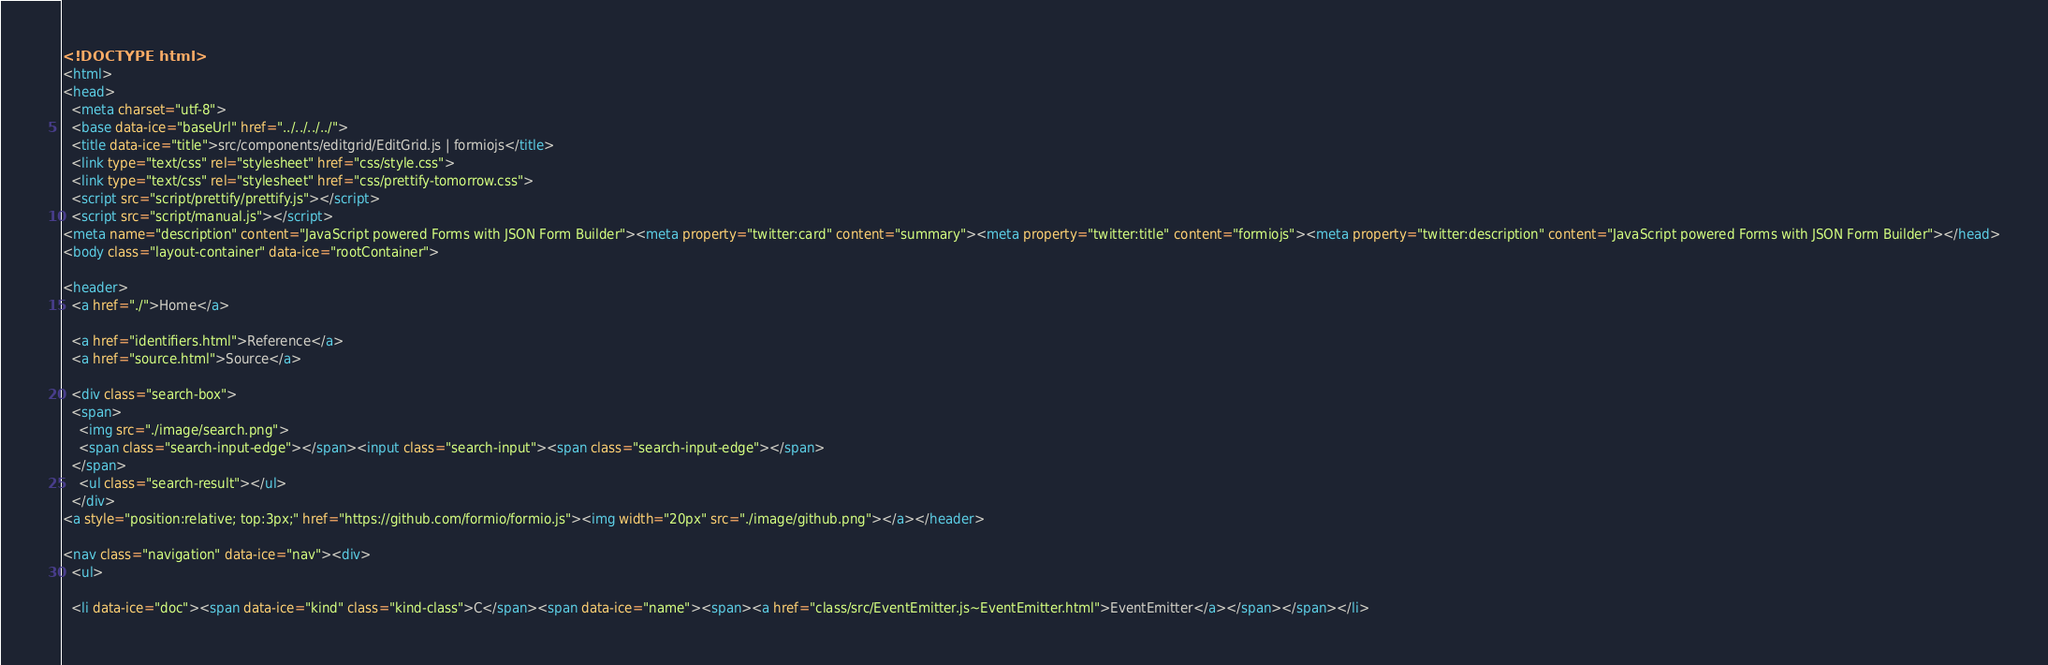<code> <loc_0><loc_0><loc_500><loc_500><_HTML_><!DOCTYPE html>
<html>
<head>
  <meta charset="utf-8">
  <base data-ice="baseUrl" href="../../../../">
  <title data-ice="title">src/components/editgrid/EditGrid.js | formiojs</title>
  <link type="text/css" rel="stylesheet" href="css/style.css">
  <link type="text/css" rel="stylesheet" href="css/prettify-tomorrow.css">
  <script src="script/prettify/prettify.js"></script>
  <script src="script/manual.js"></script>
<meta name="description" content="JavaScript powered Forms with JSON Form Builder"><meta property="twitter:card" content="summary"><meta property="twitter:title" content="formiojs"><meta property="twitter:description" content="JavaScript powered Forms with JSON Form Builder"></head>
<body class="layout-container" data-ice="rootContainer">

<header>
  <a href="./">Home</a>
  
  <a href="identifiers.html">Reference</a>
  <a href="source.html">Source</a>
  
  <div class="search-box">
  <span>
    <img src="./image/search.png">
    <span class="search-input-edge"></span><input class="search-input"><span class="search-input-edge"></span>
  </span>
    <ul class="search-result"></ul>
  </div>
<a style="position:relative; top:3px;" href="https://github.com/formio/formio.js"><img width="20px" src="./image/github.png"></a></header>

<nav class="navigation" data-ice="nav"><div>
  <ul>
    
  <li data-ice="doc"><span data-ice="kind" class="kind-class">C</span><span data-ice="name"><span><a href="class/src/EventEmitter.js~EventEmitter.html">EventEmitter</a></span></span></li></code> 